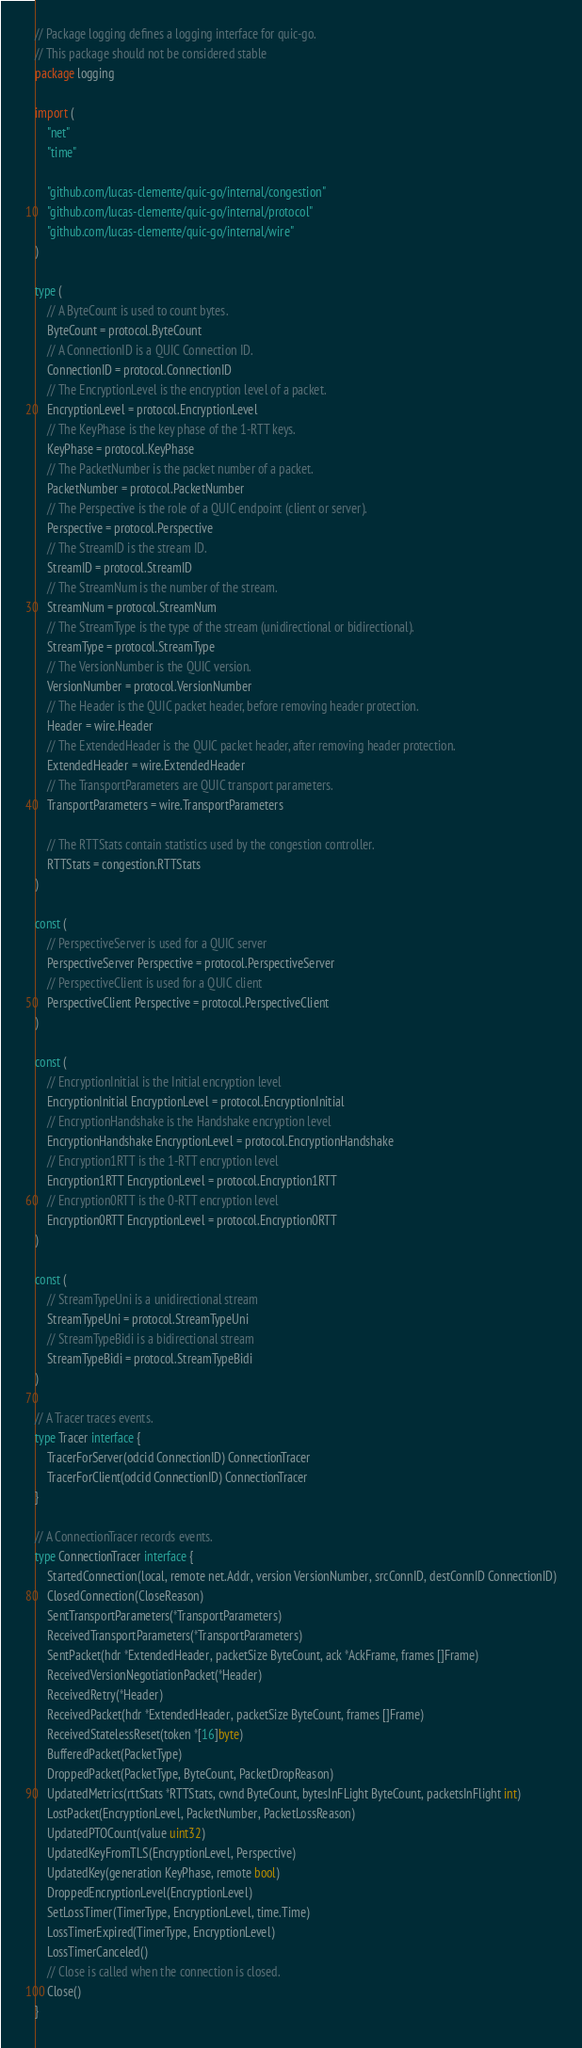<code> <loc_0><loc_0><loc_500><loc_500><_Go_>// Package logging defines a logging interface for quic-go.
// This package should not be considered stable
package logging

import (
	"net"
	"time"

	"github.com/lucas-clemente/quic-go/internal/congestion"
	"github.com/lucas-clemente/quic-go/internal/protocol"
	"github.com/lucas-clemente/quic-go/internal/wire"
)

type (
	// A ByteCount is used to count bytes.
	ByteCount = protocol.ByteCount
	// A ConnectionID is a QUIC Connection ID.
	ConnectionID = protocol.ConnectionID
	// The EncryptionLevel is the encryption level of a packet.
	EncryptionLevel = protocol.EncryptionLevel
	// The KeyPhase is the key phase of the 1-RTT keys.
	KeyPhase = protocol.KeyPhase
	// The PacketNumber is the packet number of a packet.
	PacketNumber = protocol.PacketNumber
	// The Perspective is the role of a QUIC endpoint (client or server).
	Perspective = protocol.Perspective
	// The StreamID is the stream ID.
	StreamID = protocol.StreamID
	// The StreamNum is the number of the stream.
	StreamNum = protocol.StreamNum
	// The StreamType is the type of the stream (unidirectional or bidirectional).
	StreamType = protocol.StreamType
	// The VersionNumber is the QUIC version.
	VersionNumber = protocol.VersionNumber
	// The Header is the QUIC packet header, before removing header protection.
	Header = wire.Header
	// The ExtendedHeader is the QUIC packet header, after removing header protection.
	ExtendedHeader = wire.ExtendedHeader
	// The TransportParameters are QUIC transport parameters.
	TransportParameters = wire.TransportParameters

	// The RTTStats contain statistics used by the congestion controller.
	RTTStats = congestion.RTTStats
)

const (
	// PerspectiveServer is used for a QUIC server
	PerspectiveServer Perspective = protocol.PerspectiveServer
	// PerspectiveClient is used for a QUIC client
	PerspectiveClient Perspective = protocol.PerspectiveClient
)

const (
	// EncryptionInitial is the Initial encryption level
	EncryptionInitial EncryptionLevel = protocol.EncryptionInitial
	// EncryptionHandshake is the Handshake encryption level
	EncryptionHandshake EncryptionLevel = protocol.EncryptionHandshake
	// Encryption1RTT is the 1-RTT encryption level
	Encryption1RTT EncryptionLevel = protocol.Encryption1RTT
	// Encryption0RTT is the 0-RTT encryption level
	Encryption0RTT EncryptionLevel = protocol.Encryption0RTT
)

const (
	// StreamTypeUni is a unidirectional stream
	StreamTypeUni = protocol.StreamTypeUni
	// StreamTypeBidi is a bidirectional stream
	StreamTypeBidi = protocol.StreamTypeBidi
)

// A Tracer traces events.
type Tracer interface {
	TracerForServer(odcid ConnectionID) ConnectionTracer
	TracerForClient(odcid ConnectionID) ConnectionTracer
}

// A ConnectionTracer records events.
type ConnectionTracer interface {
	StartedConnection(local, remote net.Addr, version VersionNumber, srcConnID, destConnID ConnectionID)
	ClosedConnection(CloseReason)
	SentTransportParameters(*TransportParameters)
	ReceivedTransportParameters(*TransportParameters)
	SentPacket(hdr *ExtendedHeader, packetSize ByteCount, ack *AckFrame, frames []Frame)
	ReceivedVersionNegotiationPacket(*Header)
	ReceivedRetry(*Header)
	ReceivedPacket(hdr *ExtendedHeader, packetSize ByteCount, frames []Frame)
	ReceivedStatelessReset(token *[16]byte)
	BufferedPacket(PacketType)
	DroppedPacket(PacketType, ByteCount, PacketDropReason)
	UpdatedMetrics(rttStats *RTTStats, cwnd ByteCount, bytesInFLight ByteCount, packetsInFlight int)
	LostPacket(EncryptionLevel, PacketNumber, PacketLossReason)
	UpdatedPTOCount(value uint32)
	UpdatedKeyFromTLS(EncryptionLevel, Perspective)
	UpdatedKey(generation KeyPhase, remote bool)
	DroppedEncryptionLevel(EncryptionLevel)
	SetLossTimer(TimerType, EncryptionLevel, time.Time)
	LossTimerExpired(TimerType, EncryptionLevel)
	LossTimerCanceled()
	// Close is called when the connection is closed.
	Close()
}
</code> 